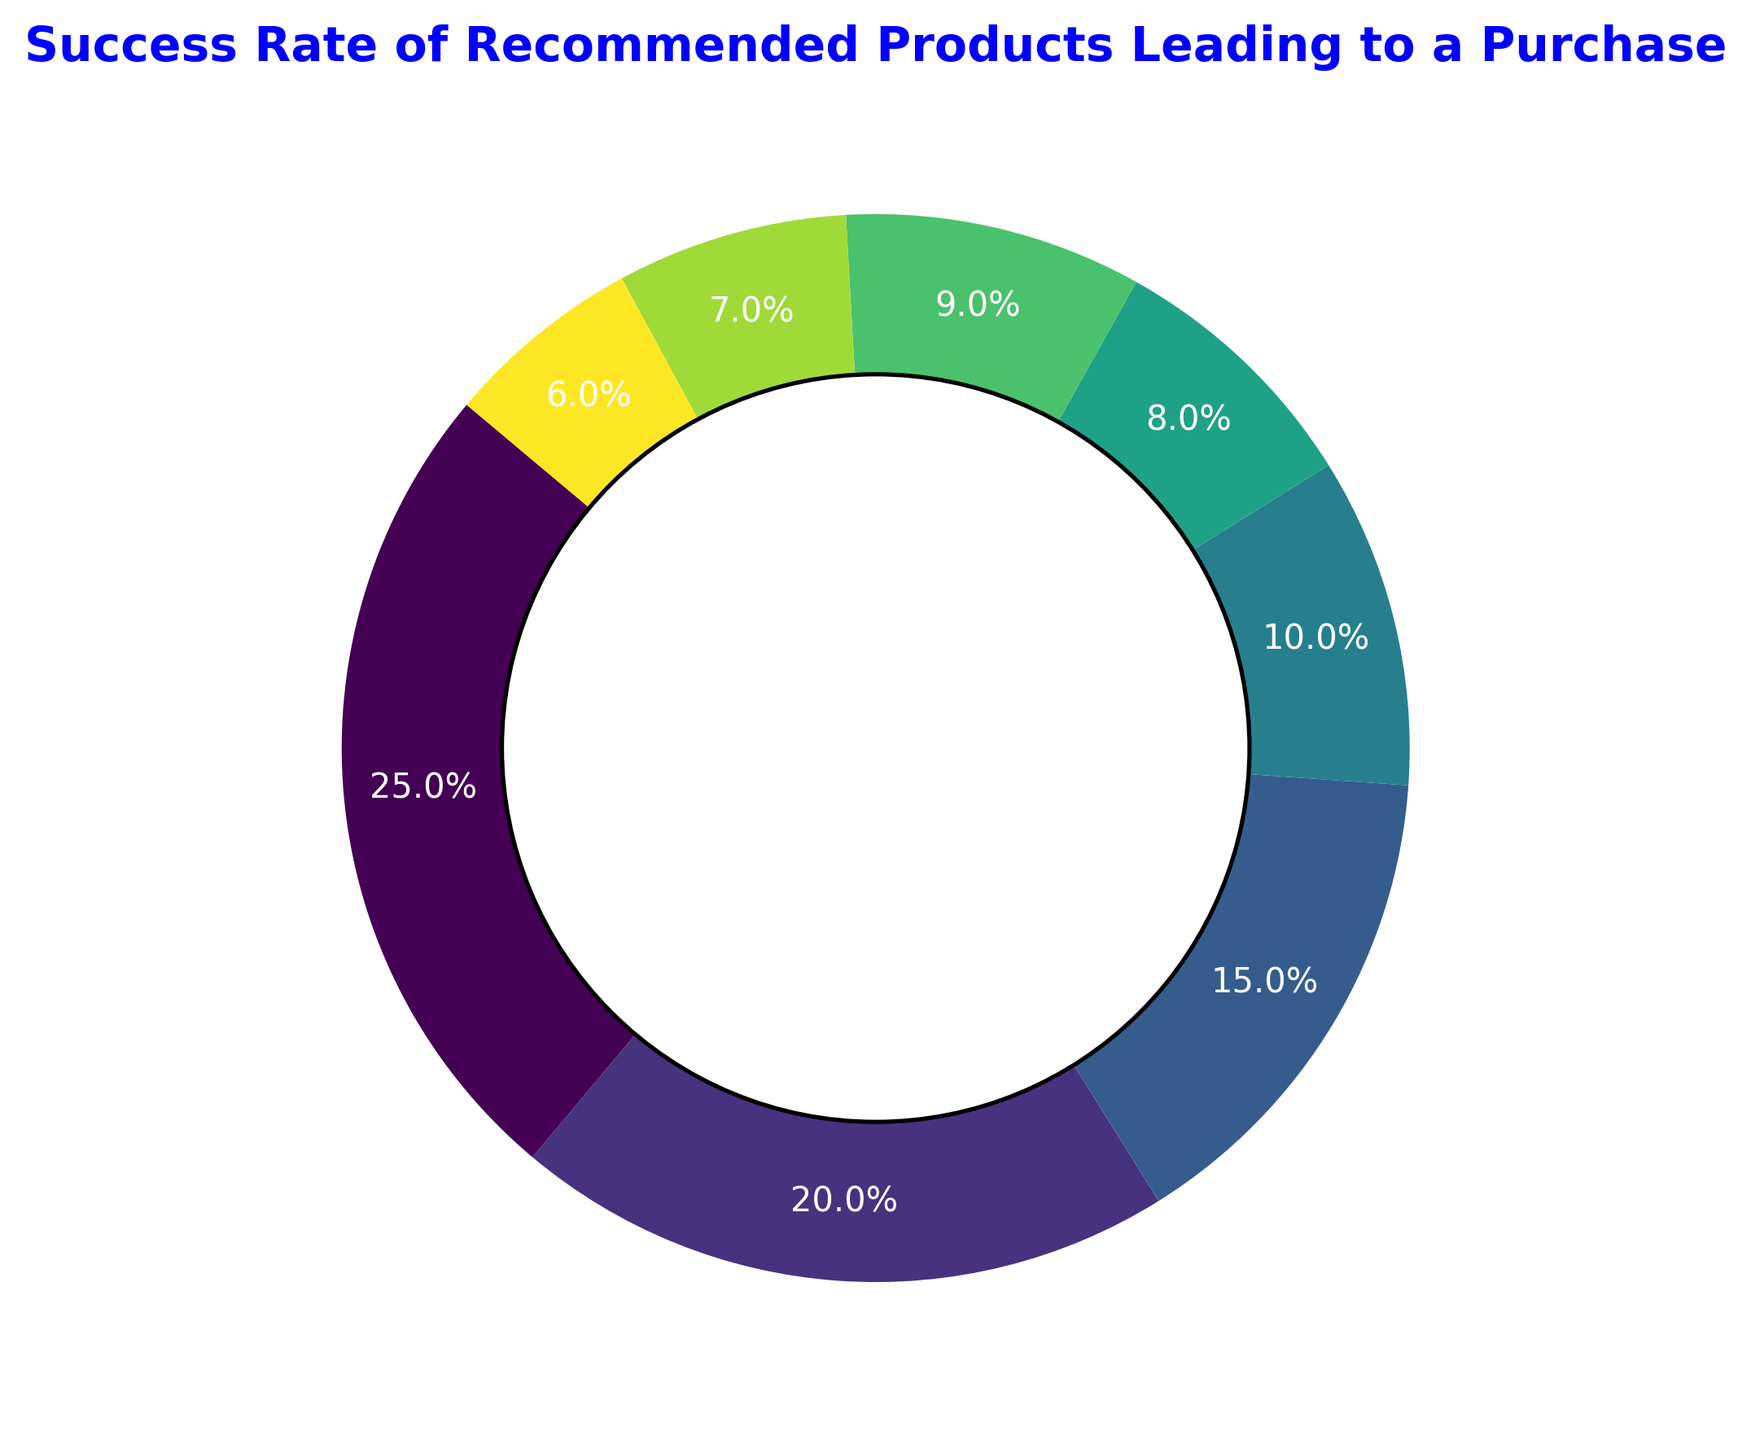Which category has the highest success rate for recommended products leading to a purchase? The category with the highest percentage on the pie chart represents the highest success rate. By looking at the chart, we see that Electronics has the largest segment.
Answer: Electronics What is the combined success rate of the Home & Kitchen and Beauty Products categories? We need to add the percentages of Home & Kitchen (15%) and Beauty Products (10%) as shown in the chart: 15% + 10% = 25%
Answer: 25% Which categories have a success rate less than 10%? We look at the chart for categories with percentages less than 10%. These categories are Books (8%), Sports & Outdoors (9%), Toys & Games (7%), and Others (6%).
Answer: Books, Sports & Outdoors, Toys & Games, Others How much greater is the success rate for Clothing compared to Books? By comparing the two percentages from the chart, Clothing (20%) and Books (8%), we calculate the difference: 20% - 8% = 12%
Answer: 12% What is the average success rate of Electronics, Clothing, and Home & Kitchen? Add the percentages of Electronics (25%), Clothing (20%), and Home & Kitchen (15%) and divide by 3: (25% + 20% + 15%) / 3 = 60% / 3 = 20%
Answer: 20% What proportion of the total success rate do Electronics and Clothing categories make up? Add the percentages of Electronics (25%) and Clothing (20%) to find their combined proportion: 25% + 20% = 45%
Answer: 45% Which category has a color that appears closest to the end of the color spectrum used in the figure? The end of the color spectrum in the color map used (viridis) is typically represented by bright yellow-green colors. Observing the color distribution, the category "Others" appears closest to this end.
Answer: Others If the sum of success rates for Beauty Products and Sports & Outdoors is less than the success rate for Home & Kitchen, what does this indicate? Beauty Products are at 10%, and Sports & Outdoors at 9%. Their combined rate is 10% + 9% = 19%, which is greater than Home & Kitchen at 15%. This indicates the combined rate of these two is higher than Home & Kitchen.
Answer: Incorrect statement What is the cumulative success rate of all categories depicted on the pie chart? Since the pie chart represents the entire distribution of categories, their combined total should sum to 100% as each category's success rate is represented as a part of the whole.
Answer: 100% 